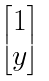<formula> <loc_0><loc_0><loc_500><loc_500>\begin{bmatrix} 1 \\ y \end{bmatrix}</formula> 